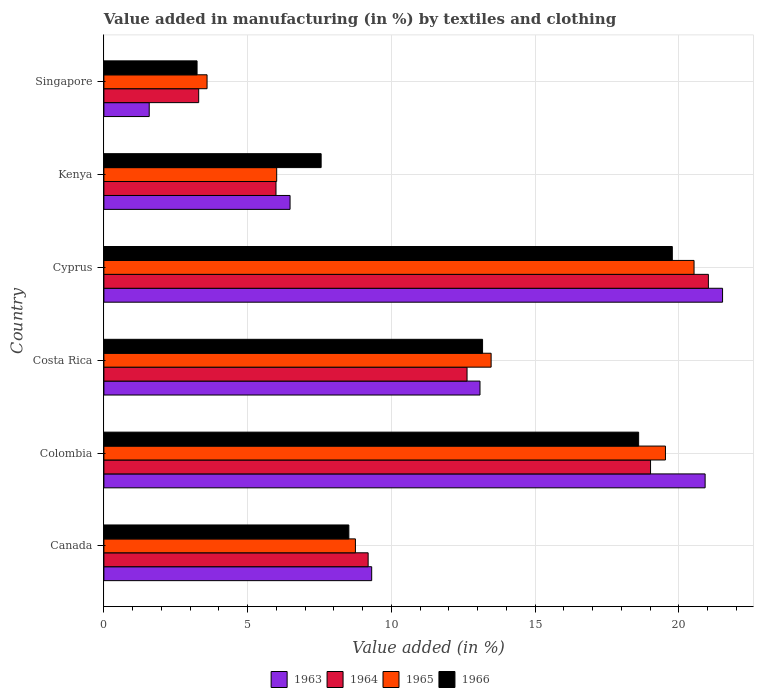Are the number of bars per tick equal to the number of legend labels?
Give a very brief answer. Yes. Are the number of bars on each tick of the Y-axis equal?
Keep it short and to the point. Yes. What is the label of the 1st group of bars from the top?
Offer a terse response. Singapore. What is the percentage of value added in manufacturing by textiles and clothing in 1966 in Kenya?
Offer a terse response. 7.56. Across all countries, what is the maximum percentage of value added in manufacturing by textiles and clothing in 1966?
Offer a very short reply. 19.78. Across all countries, what is the minimum percentage of value added in manufacturing by textiles and clothing in 1963?
Your answer should be very brief. 1.58. In which country was the percentage of value added in manufacturing by textiles and clothing in 1964 maximum?
Your response must be concise. Cyprus. In which country was the percentage of value added in manufacturing by textiles and clothing in 1965 minimum?
Your answer should be very brief. Singapore. What is the total percentage of value added in manufacturing by textiles and clothing in 1964 in the graph?
Your answer should be very brief. 71.16. What is the difference between the percentage of value added in manufacturing by textiles and clothing in 1964 in Canada and that in Singapore?
Keep it short and to the point. 5.9. What is the difference between the percentage of value added in manufacturing by textiles and clothing in 1966 in Cyprus and the percentage of value added in manufacturing by textiles and clothing in 1964 in Canada?
Provide a short and direct response. 10.58. What is the average percentage of value added in manufacturing by textiles and clothing in 1963 per country?
Your response must be concise. 12.15. What is the difference between the percentage of value added in manufacturing by textiles and clothing in 1966 and percentage of value added in manufacturing by textiles and clothing in 1965 in Colombia?
Offer a terse response. -0.93. What is the ratio of the percentage of value added in manufacturing by textiles and clothing in 1963 in Canada to that in Kenya?
Provide a short and direct response. 1.44. Is the percentage of value added in manufacturing by textiles and clothing in 1963 in Canada less than that in Kenya?
Offer a very short reply. No. What is the difference between the highest and the second highest percentage of value added in manufacturing by textiles and clothing in 1963?
Make the answer very short. 0.61. What is the difference between the highest and the lowest percentage of value added in manufacturing by textiles and clothing in 1964?
Your response must be concise. 17.73. Is the sum of the percentage of value added in manufacturing by textiles and clothing in 1963 in Canada and Kenya greater than the maximum percentage of value added in manufacturing by textiles and clothing in 1964 across all countries?
Your response must be concise. No. What does the 3rd bar from the bottom in Singapore represents?
Provide a succinct answer. 1965. How many bars are there?
Keep it short and to the point. 24. What is the difference between two consecutive major ticks on the X-axis?
Your answer should be very brief. 5. Are the values on the major ticks of X-axis written in scientific E-notation?
Make the answer very short. No. Does the graph contain any zero values?
Offer a very short reply. No. How many legend labels are there?
Keep it short and to the point. 4. What is the title of the graph?
Provide a succinct answer. Value added in manufacturing (in %) by textiles and clothing. What is the label or title of the X-axis?
Offer a terse response. Value added (in %). What is the label or title of the Y-axis?
Provide a succinct answer. Country. What is the Value added (in %) of 1963 in Canada?
Provide a succinct answer. 9.32. What is the Value added (in %) in 1964 in Canada?
Make the answer very short. 9.19. What is the Value added (in %) in 1965 in Canada?
Ensure brevity in your answer.  8.75. What is the Value added (in %) in 1966 in Canada?
Your answer should be compact. 8.52. What is the Value added (in %) in 1963 in Colombia?
Offer a terse response. 20.92. What is the Value added (in %) in 1964 in Colombia?
Make the answer very short. 19.02. What is the Value added (in %) in 1965 in Colombia?
Give a very brief answer. 19.54. What is the Value added (in %) in 1966 in Colombia?
Provide a succinct answer. 18.6. What is the Value added (in %) of 1963 in Costa Rica?
Make the answer very short. 13.08. What is the Value added (in %) in 1964 in Costa Rica?
Your answer should be very brief. 12.63. What is the Value added (in %) in 1965 in Costa Rica?
Your answer should be very brief. 13.47. What is the Value added (in %) of 1966 in Costa Rica?
Make the answer very short. 13.17. What is the Value added (in %) of 1963 in Cyprus?
Your answer should be very brief. 21.52. What is the Value added (in %) of 1964 in Cyprus?
Offer a very short reply. 21.03. What is the Value added (in %) of 1965 in Cyprus?
Offer a terse response. 20.53. What is the Value added (in %) in 1966 in Cyprus?
Make the answer very short. 19.78. What is the Value added (in %) in 1963 in Kenya?
Your response must be concise. 6.48. What is the Value added (in %) of 1964 in Kenya?
Offer a very short reply. 5.99. What is the Value added (in %) of 1965 in Kenya?
Provide a succinct answer. 6.01. What is the Value added (in %) of 1966 in Kenya?
Offer a very short reply. 7.56. What is the Value added (in %) of 1963 in Singapore?
Offer a very short reply. 1.58. What is the Value added (in %) of 1964 in Singapore?
Your answer should be compact. 3.3. What is the Value added (in %) in 1965 in Singapore?
Give a very brief answer. 3.59. What is the Value added (in %) in 1966 in Singapore?
Provide a succinct answer. 3.24. Across all countries, what is the maximum Value added (in %) of 1963?
Make the answer very short. 21.52. Across all countries, what is the maximum Value added (in %) of 1964?
Provide a succinct answer. 21.03. Across all countries, what is the maximum Value added (in %) in 1965?
Give a very brief answer. 20.53. Across all countries, what is the maximum Value added (in %) in 1966?
Make the answer very short. 19.78. Across all countries, what is the minimum Value added (in %) in 1963?
Offer a very short reply. 1.58. Across all countries, what is the minimum Value added (in %) of 1964?
Offer a terse response. 3.3. Across all countries, what is the minimum Value added (in %) in 1965?
Ensure brevity in your answer.  3.59. Across all countries, what is the minimum Value added (in %) of 1966?
Provide a short and direct response. 3.24. What is the total Value added (in %) of 1963 in the graph?
Keep it short and to the point. 72.9. What is the total Value added (in %) in 1964 in the graph?
Offer a terse response. 71.16. What is the total Value added (in %) in 1965 in the graph?
Your answer should be very brief. 71.89. What is the total Value added (in %) of 1966 in the graph?
Your answer should be compact. 70.87. What is the difference between the Value added (in %) of 1963 in Canada and that in Colombia?
Offer a very short reply. -11.6. What is the difference between the Value added (in %) of 1964 in Canada and that in Colombia?
Your response must be concise. -9.82. What is the difference between the Value added (in %) of 1965 in Canada and that in Colombia?
Ensure brevity in your answer.  -10.79. What is the difference between the Value added (in %) of 1966 in Canada and that in Colombia?
Your response must be concise. -10.08. What is the difference between the Value added (in %) of 1963 in Canada and that in Costa Rica?
Your response must be concise. -3.77. What is the difference between the Value added (in %) in 1964 in Canada and that in Costa Rica?
Your response must be concise. -3.44. What is the difference between the Value added (in %) in 1965 in Canada and that in Costa Rica?
Ensure brevity in your answer.  -4.72. What is the difference between the Value added (in %) in 1966 in Canada and that in Costa Rica?
Give a very brief answer. -4.65. What is the difference between the Value added (in %) of 1963 in Canada and that in Cyprus?
Offer a terse response. -12.21. What is the difference between the Value added (in %) in 1964 in Canada and that in Cyprus?
Ensure brevity in your answer.  -11.84. What is the difference between the Value added (in %) of 1965 in Canada and that in Cyprus?
Provide a short and direct response. -11.78. What is the difference between the Value added (in %) of 1966 in Canada and that in Cyprus?
Ensure brevity in your answer.  -11.25. What is the difference between the Value added (in %) in 1963 in Canada and that in Kenya?
Your response must be concise. 2.84. What is the difference between the Value added (in %) in 1964 in Canada and that in Kenya?
Make the answer very short. 3.21. What is the difference between the Value added (in %) in 1965 in Canada and that in Kenya?
Your answer should be compact. 2.74. What is the difference between the Value added (in %) of 1966 in Canada and that in Kenya?
Your response must be concise. 0.96. What is the difference between the Value added (in %) of 1963 in Canada and that in Singapore?
Your answer should be compact. 7.74. What is the difference between the Value added (in %) in 1964 in Canada and that in Singapore?
Provide a short and direct response. 5.9. What is the difference between the Value added (in %) in 1965 in Canada and that in Singapore?
Your response must be concise. 5.16. What is the difference between the Value added (in %) in 1966 in Canada and that in Singapore?
Make the answer very short. 5.28. What is the difference between the Value added (in %) of 1963 in Colombia and that in Costa Rica?
Make the answer very short. 7.83. What is the difference between the Value added (in %) of 1964 in Colombia and that in Costa Rica?
Provide a succinct answer. 6.38. What is the difference between the Value added (in %) in 1965 in Colombia and that in Costa Rica?
Ensure brevity in your answer.  6.06. What is the difference between the Value added (in %) in 1966 in Colombia and that in Costa Rica?
Your answer should be very brief. 5.43. What is the difference between the Value added (in %) of 1963 in Colombia and that in Cyprus?
Give a very brief answer. -0.61. What is the difference between the Value added (in %) of 1964 in Colombia and that in Cyprus?
Keep it short and to the point. -2.01. What is the difference between the Value added (in %) in 1965 in Colombia and that in Cyprus?
Keep it short and to the point. -0.99. What is the difference between the Value added (in %) of 1966 in Colombia and that in Cyprus?
Provide a succinct answer. -1.17. What is the difference between the Value added (in %) of 1963 in Colombia and that in Kenya?
Give a very brief answer. 14.44. What is the difference between the Value added (in %) of 1964 in Colombia and that in Kenya?
Your response must be concise. 13.03. What is the difference between the Value added (in %) in 1965 in Colombia and that in Kenya?
Your answer should be very brief. 13.53. What is the difference between the Value added (in %) in 1966 in Colombia and that in Kenya?
Give a very brief answer. 11.05. What is the difference between the Value added (in %) of 1963 in Colombia and that in Singapore?
Offer a terse response. 19.34. What is the difference between the Value added (in %) of 1964 in Colombia and that in Singapore?
Keep it short and to the point. 15.72. What is the difference between the Value added (in %) in 1965 in Colombia and that in Singapore?
Keep it short and to the point. 15.95. What is the difference between the Value added (in %) of 1966 in Colombia and that in Singapore?
Keep it short and to the point. 15.36. What is the difference between the Value added (in %) of 1963 in Costa Rica and that in Cyprus?
Provide a succinct answer. -8.44. What is the difference between the Value added (in %) in 1964 in Costa Rica and that in Cyprus?
Ensure brevity in your answer.  -8.4. What is the difference between the Value added (in %) in 1965 in Costa Rica and that in Cyprus?
Your answer should be very brief. -7.06. What is the difference between the Value added (in %) of 1966 in Costa Rica and that in Cyprus?
Keep it short and to the point. -6.6. What is the difference between the Value added (in %) of 1963 in Costa Rica and that in Kenya?
Offer a terse response. 6.61. What is the difference between the Value added (in %) of 1964 in Costa Rica and that in Kenya?
Offer a terse response. 6.65. What is the difference between the Value added (in %) in 1965 in Costa Rica and that in Kenya?
Give a very brief answer. 7.46. What is the difference between the Value added (in %) in 1966 in Costa Rica and that in Kenya?
Give a very brief answer. 5.62. What is the difference between the Value added (in %) in 1963 in Costa Rica and that in Singapore?
Your answer should be compact. 11.51. What is the difference between the Value added (in %) of 1964 in Costa Rica and that in Singapore?
Provide a succinct answer. 9.34. What is the difference between the Value added (in %) of 1965 in Costa Rica and that in Singapore?
Your response must be concise. 9.88. What is the difference between the Value added (in %) in 1966 in Costa Rica and that in Singapore?
Ensure brevity in your answer.  9.93. What is the difference between the Value added (in %) in 1963 in Cyprus and that in Kenya?
Provide a succinct answer. 15.05. What is the difference between the Value added (in %) in 1964 in Cyprus and that in Kenya?
Your response must be concise. 15.04. What is the difference between the Value added (in %) in 1965 in Cyprus and that in Kenya?
Give a very brief answer. 14.52. What is the difference between the Value added (in %) of 1966 in Cyprus and that in Kenya?
Your answer should be very brief. 12.22. What is the difference between the Value added (in %) in 1963 in Cyprus and that in Singapore?
Your answer should be compact. 19.95. What is the difference between the Value added (in %) in 1964 in Cyprus and that in Singapore?
Offer a very short reply. 17.73. What is the difference between the Value added (in %) of 1965 in Cyprus and that in Singapore?
Your response must be concise. 16.94. What is the difference between the Value added (in %) in 1966 in Cyprus and that in Singapore?
Offer a terse response. 16.53. What is the difference between the Value added (in %) in 1963 in Kenya and that in Singapore?
Offer a terse response. 4.9. What is the difference between the Value added (in %) in 1964 in Kenya and that in Singapore?
Offer a very short reply. 2.69. What is the difference between the Value added (in %) of 1965 in Kenya and that in Singapore?
Make the answer very short. 2.42. What is the difference between the Value added (in %) in 1966 in Kenya and that in Singapore?
Your response must be concise. 4.32. What is the difference between the Value added (in %) in 1963 in Canada and the Value added (in %) in 1964 in Colombia?
Provide a short and direct response. -9.7. What is the difference between the Value added (in %) in 1963 in Canada and the Value added (in %) in 1965 in Colombia?
Give a very brief answer. -10.22. What is the difference between the Value added (in %) in 1963 in Canada and the Value added (in %) in 1966 in Colombia?
Provide a succinct answer. -9.29. What is the difference between the Value added (in %) in 1964 in Canada and the Value added (in %) in 1965 in Colombia?
Keep it short and to the point. -10.34. What is the difference between the Value added (in %) in 1964 in Canada and the Value added (in %) in 1966 in Colombia?
Offer a very short reply. -9.41. What is the difference between the Value added (in %) of 1965 in Canada and the Value added (in %) of 1966 in Colombia?
Your response must be concise. -9.85. What is the difference between the Value added (in %) of 1963 in Canada and the Value added (in %) of 1964 in Costa Rica?
Ensure brevity in your answer.  -3.32. What is the difference between the Value added (in %) of 1963 in Canada and the Value added (in %) of 1965 in Costa Rica?
Provide a succinct answer. -4.16. What is the difference between the Value added (in %) in 1963 in Canada and the Value added (in %) in 1966 in Costa Rica?
Ensure brevity in your answer.  -3.86. What is the difference between the Value added (in %) in 1964 in Canada and the Value added (in %) in 1965 in Costa Rica?
Make the answer very short. -4.28. What is the difference between the Value added (in %) of 1964 in Canada and the Value added (in %) of 1966 in Costa Rica?
Offer a very short reply. -3.98. What is the difference between the Value added (in %) of 1965 in Canada and the Value added (in %) of 1966 in Costa Rica?
Your answer should be compact. -4.42. What is the difference between the Value added (in %) in 1963 in Canada and the Value added (in %) in 1964 in Cyprus?
Keep it short and to the point. -11.71. What is the difference between the Value added (in %) of 1963 in Canada and the Value added (in %) of 1965 in Cyprus?
Your answer should be compact. -11.21. What is the difference between the Value added (in %) of 1963 in Canada and the Value added (in %) of 1966 in Cyprus?
Offer a terse response. -10.46. What is the difference between the Value added (in %) in 1964 in Canada and the Value added (in %) in 1965 in Cyprus?
Your answer should be compact. -11.34. What is the difference between the Value added (in %) in 1964 in Canada and the Value added (in %) in 1966 in Cyprus?
Offer a terse response. -10.58. What is the difference between the Value added (in %) in 1965 in Canada and the Value added (in %) in 1966 in Cyprus?
Give a very brief answer. -11.02. What is the difference between the Value added (in %) in 1963 in Canada and the Value added (in %) in 1964 in Kenya?
Keep it short and to the point. 3.33. What is the difference between the Value added (in %) of 1963 in Canada and the Value added (in %) of 1965 in Kenya?
Give a very brief answer. 3.31. What is the difference between the Value added (in %) in 1963 in Canada and the Value added (in %) in 1966 in Kenya?
Your answer should be compact. 1.76. What is the difference between the Value added (in %) of 1964 in Canada and the Value added (in %) of 1965 in Kenya?
Your answer should be compact. 3.18. What is the difference between the Value added (in %) in 1964 in Canada and the Value added (in %) in 1966 in Kenya?
Make the answer very short. 1.64. What is the difference between the Value added (in %) in 1965 in Canada and the Value added (in %) in 1966 in Kenya?
Offer a terse response. 1.19. What is the difference between the Value added (in %) in 1963 in Canada and the Value added (in %) in 1964 in Singapore?
Ensure brevity in your answer.  6.02. What is the difference between the Value added (in %) in 1963 in Canada and the Value added (in %) in 1965 in Singapore?
Your answer should be very brief. 5.73. What is the difference between the Value added (in %) in 1963 in Canada and the Value added (in %) in 1966 in Singapore?
Your response must be concise. 6.08. What is the difference between the Value added (in %) in 1964 in Canada and the Value added (in %) in 1965 in Singapore?
Ensure brevity in your answer.  5.6. What is the difference between the Value added (in %) of 1964 in Canada and the Value added (in %) of 1966 in Singapore?
Offer a terse response. 5.95. What is the difference between the Value added (in %) of 1965 in Canada and the Value added (in %) of 1966 in Singapore?
Give a very brief answer. 5.51. What is the difference between the Value added (in %) in 1963 in Colombia and the Value added (in %) in 1964 in Costa Rica?
Offer a very short reply. 8.28. What is the difference between the Value added (in %) of 1963 in Colombia and the Value added (in %) of 1965 in Costa Rica?
Your answer should be compact. 7.44. What is the difference between the Value added (in %) in 1963 in Colombia and the Value added (in %) in 1966 in Costa Rica?
Give a very brief answer. 7.74. What is the difference between the Value added (in %) of 1964 in Colombia and the Value added (in %) of 1965 in Costa Rica?
Offer a very short reply. 5.55. What is the difference between the Value added (in %) of 1964 in Colombia and the Value added (in %) of 1966 in Costa Rica?
Offer a very short reply. 5.84. What is the difference between the Value added (in %) in 1965 in Colombia and the Value added (in %) in 1966 in Costa Rica?
Provide a short and direct response. 6.36. What is the difference between the Value added (in %) of 1963 in Colombia and the Value added (in %) of 1964 in Cyprus?
Offer a very short reply. -0.11. What is the difference between the Value added (in %) of 1963 in Colombia and the Value added (in %) of 1965 in Cyprus?
Provide a short and direct response. 0.39. What is the difference between the Value added (in %) of 1963 in Colombia and the Value added (in %) of 1966 in Cyprus?
Your response must be concise. 1.14. What is the difference between the Value added (in %) in 1964 in Colombia and the Value added (in %) in 1965 in Cyprus?
Your answer should be very brief. -1.51. What is the difference between the Value added (in %) of 1964 in Colombia and the Value added (in %) of 1966 in Cyprus?
Provide a short and direct response. -0.76. What is the difference between the Value added (in %) of 1965 in Colombia and the Value added (in %) of 1966 in Cyprus?
Keep it short and to the point. -0.24. What is the difference between the Value added (in %) in 1963 in Colombia and the Value added (in %) in 1964 in Kenya?
Offer a terse response. 14.93. What is the difference between the Value added (in %) of 1963 in Colombia and the Value added (in %) of 1965 in Kenya?
Offer a very short reply. 14.91. What is the difference between the Value added (in %) in 1963 in Colombia and the Value added (in %) in 1966 in Kenya?
Offer a terse response. 13.36. What is the difference between the Value added (in %) in 1964 in Colombia and the Value added (in %) in 1965 in Kenya?
Give a very brief answer. 13.01. What is the difference between the Value added (in %) of 1964 in Colombia and the Value added (in %) of 1966 in Kenya?
Ensure brevity in your answer.  11.46. What is the difference between the Value added (in %) of 1965 in Colombia and the Value added (in %) of 1966 in Kenya?
Offer a very short reply. 11.98. What is the difference between the Value added (in %) in 1963 in Colombia and the Value added (in %) in 1964 in Singapore?
Offer a terse response. 17.62. What is the difference between the Value added (in %) in 1963 in Colombia and the Value added (in %) in 1965 in Singapore?
Ensure brevity in your answer.  17.33. What is the difference between the Value added (in %) in 1963 in Colombia and the Value added (in %) in 1966 in Singapore?
Ensure brevity in your answer.  17.68. What is the difference between the Value added (in %) of 1964 in Colombia and the Value added (in %) of 1965 in Singapore?
Give a very brief answer. 15.43. What is the difference between the Value added (in %) in 1964 in Colombia and the Value added (in %) in 1966 in Singapore?
Your answer should be very brief. 15.78. What is the difference between the Value added (in %) in 1965 in Colombia and the Value added (in %) in 1966 in Singapore?
Offer a terse response. 16.3. What is the difference between the Value added (in %) in 1963 in Costa Rica and the Value added (in %) in 1964 in Cyprus?
Keep it short and to the point. -7.95. What is the difference between the Value added (in %) of 1963 in Costa Rica and the Value added (in %) of 1965 in Cyprus?
Provide a short and direct response. -7.45. What is the difference between the Value added (in %) of 1963 in Costa Rica and the Value added (in %) of 1966 in Cyprus?
Give a very brief answer. -6.69. What is the difference between the Value added (in %) of 1964 in Costa Rica and the Value added (in %) of 1965 in Cyprus?
Your answer should be compact. -7.9. What is the difference between the Value added (in %) in 1964 in Costa Rica and the Value added (in %) in 1966 in Cyprus?
Your response must be concise. -7.14. What is the difference between the Value added (in %) in 1965 in Costa Rica and the Value added (in %) in 1966 in Cyprus?
Ensure brevity in your answer.  -6.3. What is the difference between the Value added (in %) in 1963 in Costa Rica and the Value added (in %) in 1964 in Kenya?
Keep it short and to the point. 7.1. What is the difference between the Value added (in %) in 1963 in Costa Rica and the Value added (in %) in 1965 in Kenya?
Your response must be concise. 7.07. What is the difference between the Value added (in %) of 1963 in Costa Rica and the Value added (in %) of 1966 in Kenya?
Your answer should be compact. 5.53. What is the difference between the Value added (in %) in 1964 in Costa Rica and the Value added (in %) in 1965 in Kenya?
Provide a short and direct response. 6.62. What is the difference between the Value added (in %) of 1964 in Costa Rica and the Value added (in %) of 1966 in Kenya?
Your answer should be compact. 5.08. What is the difference between the Value added (in %) in 1965 in Costa Rica and the Value added (in %) in 1966 in Kenya?
Make the answer very short. 5.91. What is the difference between the Value added (in %) of 1963 in Costa Rica and the Value added (in %) of 1964 in Singapore?
Provide a succinct answer. 9.79. What is the difference between the Value added (in %) in 1963 in Costa Rica and the Value added (in %) in 1965 in Singapore?
Provide a succinct answer. 9.5. What is the difference between the Value added (in %) in 1963 in Costa Rica and the Value added (in %) in 1966 in Singapore?
Make the answer very short. 9.84. What is the difference between the Value added (in %) in 1964 in Costa Rica and the Value added (in %) in 1965 in Singapore?
Your response must be concise. 9.04. What is the difference between the Value added (in %) in 1964 in Costa Rica and the Value added (in %) in 1966 in Singapore?
Provide a succinct answer. 9.39. What is the difference between the Value added (in %) of 1965 in Costa Rica and the Value added (in %) of 1966 in Singapore?
Keep it short and to the point. 10.23. What is the difference between the Value added (in %) of 1963 in Cyprus and the Value added (in %) of 1964 in Kenya?
Offer a terse response. 15.54. What is the difference between the Value added (in %) in 1963 in Cyprus and the Value added (in %) in 1965 in Kenya?
Make the answer very short. 15.51. What is the difference between the Value added (in %) in 1963 in Cyprus and the Value added (in %) in 1966 in Kenya?
Provide a short and direct response. 13.97. What is the difference between the Value added (in %) in 1964 in Cyprus and the Value added (in %) in 1965 in Kenya?
Provide a short and direct response. 15.02. What is the difference between the Value added (in %) of 1964 in Cyprus and the Value added (in %) of 1966 in Kenya?
Offer a very short reply. 13.47. What is the difference between the Value added (in %) in 1965 in Cyprus and the Value added (in %) in 1966 in Kenya?
Give a very brief answer. 12.97. What is the difference between the Value added (in %) of 1963 in Cyprus and the Value added (in %) of 1964 in Singapore?
Keep it short and to the point. 18.23. What is the difference between the Value added (in %) in 1963 in Cyprus and the Value added (in %) in 1965 in Singapore?
Provide a short and direct response. 17.93. What is the difference between the Value added (in %) in 1963 in Cyprus and the Value added (in %) in 1966 in Singapore?
Your answer should be very brief. 18.28. What is the difference between the Value added (in %) in 1964 in Cyprus and the Value added (in %) in 1965 in Singapore?
Your answer should be compact. 17.44. What is the difference between the Value added (in %) of 1964 in Cyprus and the Value added (in %) of 1966 in Singapore?
Your answer should be compact. 17.79. What is the difference between the Value added (in %) in 1965 in Cyprus and the Value added (in %) in 1966 in Singapore?
Make the answer very short. 17.29. What is the difference between the Value added (in %) of 1963 in Kenya and the Value added (in %) of 1964 in Singapore?
Provide a short and direct response. 3.18. What is the difference between the Value added (in %) of 1963 in Kenya and the Value added (in %) of 1965 in Singapore?
Make the answer very short. 2.89. What is the difference between the Value added (in %) of 1963 in Kenya and the Value added (in %) of 1966 in Singapore?
Make the answer very short. 3.24. What is the difference between the Value added (in %) in 1964 in Kenya and the Value added (in %) in 1965 in Singapore?
Provide a succinct answer. 2.4. What is the difference between the Value added (in %) in 1964 in Kenya and the Value added (in %) in 1966 in Singapore?
Ensure brevity in your answer.  2.75. What is the difference between the Value added (in %) in 1965 in Kenya and the Value added (in %) in 1966 in Singapore?
Make the answer very short. 2.77. What is the average Value added (in %) in 1963 per country?
Your response must be concise. 12.15. What is the average Value added (in %) in 1964 per country?
Provide a short and direct response. 11.86. What is the average Value added (in %) of 1965 per country?
Make the answer very short. 11.98. What is the average Value added (in %) of 1966 per country?
Your answer should be very brief. 11.81. What is the difference between the Value added (in %) in 1963 and Value added (in %) in 1964 in Canada?
Give a very brief answer. 0.12. What is the difference between the Value added (in %) in 1963 and Value added (in %) in 1965 in Canada?
Your response must be concise. 0.57. What is the difference between the Value added (in %) of 1963 and Value added (in %) of 1966 in Canada?
Ensure brevity in your answer.  0.8. What is the difference between the Value added (in %) in 1964 and Value added (in %) in 1965 in Canada?
Provide a succinct answer. 0.44. What is the difference between the Value added (in %) of 1964 and Value added (in %) of 1966 in Canada?
Ensure brevity in your answer.  0.67. What is the difference between the Value added (in %) of 1965 and Value added (in %) of 1966 in Canada?
Make the answer very short. 0.23. What is the difference between the Value added (in %) in 1963 and Value added (in %) in 1964 in Colombia?
Keep it short and to the point. 1.9. What is the difference between the Value added (in %) of 1963 and Value added (in %) of 1965 in Colombia?
Keep it short and to the point. 1.38. What is the difference between the Value added (in %) in 1963 and Value added (in %) in 1966 in Colombia?
Your answer should be compact. 2.31. What is the difference between the Value added (in %) in 1964 and Value added (in %) in 1965 in Colombia?
Offer a very short reply. -0.52. What is the difference between the Value added (in %) of 1964 and Value added (in %) of 1966 in Colombia?
Offer a very short reply. 0.41. What is the difference between the Value added (in %) in 1965 and Value added (in %) in 1966 in Colombia?
Ensure brevity in your answer.  0.93. What is the difference between the Value added (in %) of 1963 and Value added (in %) of 1964 in Costa Rica?
Your answer should be very brief. 0.45. What is the difference between the Value added (in %) of 1963 and Value added (in %) of 1965 in Costa Rica?
Ensure brevity in your answer.  -0.39. What is the difference between the Value added (in %) of 1963 and Value added (in %) of 1966 in Costa Rica?
Provide a succinct answer. -0.09. What is the difference between the Value added (in %) of 1964 and Value added (in %) of 1965 in Costa Rica?
Provide a succinct answer. -0.84. What is the difference between the Value added (in %) of 1964 and Value added (in %) of 1966 in Costa Rica?
Make the answer very short. -0.54. What is the difference between the Value added (in %) of 1965 and Value added (in %) of 1966 in Costa Rica?
Offer a very short reply. 0.3. What is the difference between the Value added (in %) in 1963 and Value added (in %) in 1964 in Cyprus?
Make the answer very short. 0.49. What is the difference between the Value added (in %) in 1963 and Value added (in %) in 1966 in Cyprus?
Offer a terse response. 1.75. What is the difference between the Value added (in %) of 1964 and Value added (in %) of 1965 in Cyprus?
Offer a very short reply. 0.5. What is the difference between the Value added (in %) of 1964 and Value added (in %) of 1966 in Cyprus?
Give a very brief answer. 1.25. What is the difference between the Value added (in %) of 1965 and Value added (in %) of 1966 in Cyprus?
Make the answer very short. 0.76. What is the difference between the Value added (in %) of 1963 and Value added (in %) of 1964 in Kenya?
Offer a terse response. 0.49. What is the difference between the Value added (in %) in 1963 and Value added (in %) in 1965 in Kenya?
Your answer should be compact. 0.47. What is the difference between the Value added (in %) in 1963 and Value added (in %) in 1966 in Kenya?
Make the answer very short. -1.08. What is the difference between the Value added (in %) of 1964 and Value added (in %) of 1965 in Kenya?
Offer a very short reply. -0.02. What is the difference between the Value added (in %) in 1964 and Value added (in %) in 1966 in Kenya?
Keep it short and to the point. -1.57. What is the difference between the Value added (in %) of 1965 and Value added (in %) of 1966 in Kenya?
Provide a short and direct response. -1.55. What is the difference between the Value added (in %) in 1963 and Value added (in %) in 1964 in Singapore?
Give a very brief answer. -1.72. What is the difference between the Value added (in %) in 1963 and Value added (in %) in 1965 in Singapore?
Your answer should be very brief. -2.01. What is the difference between the Value added (in %) of 1963 and Value added (in %) of 1966 in Singapore?
Provide a succinct answer. -1.66. What is the difference between the Value added (in %) of 1964 and Value added (in %) of 1965 in Singapore?
Offer a very short reply. -0.29. What is the difference between the Value added (in %) of 1964 and Value added (in %) of 1966 in Singapore?
Your response must be concise. 0.06. What is the difference between the Value added (in %) of 1965 and Value added (in %) of 1966 in Singapore?
Offer a terse response. 0.35. What is the ratio of the Value added (in %) in 1963 in Canada to that in Colombia?
Ensure brevity in your answer.  0.45. What is the ratio of the Value added (in %) in 1964 in Canada to that in Colombia?
Offer a very short reply. 0.48. What is the ratio of the Value added (in %) of 1965 in Canada to that in Colombia?
Ensure brevity in your answer.  0.45. What is the ratio of the Value added (in %) of 1966 in Canada to that in Colombia?
Ensure brevity in your answer.  0.46. What is the ratio of the Value added (in %) in 1963 in Canada to that in Costa Rica?
Ensure brevity in your answer.  0.71. What is the ratio of the Value added (in %) of 1964 in Canada to that in Costa Rica?
Provide a succinct answer. 0.73. What is the ratio of the Value added (in %) of 1965 in Canada to that in Costa Rica?
Make the answer very short. 0.65. What is the ratio of the Value added (in %) in 1966 in Canada to that in Costa Rica?
Your response must be concise. 0.65. What is the ratio of the Value added (in %) in 1963 in Canada to that in Cyprus?
Make the answer very short. 0.43. What is the ratio of the Value added (in %) in 1964 in Canada to that in Cyprus?
Your response must be concise. 0.44. What is the ratio of the Value added (in %) in 1965 in Canada to that in Cyprus?
Provide a short and direct response. 0.43. What is the ratio of the Value added (in %) of 1966 in Canada to that in Cyprus?
Your response must be concise. 0.43. What is the ratio of the Value added (in %) in 1963 in Canada to that in Kenya?
Provide a short and direct response. 1.44. What is the ratio of the Value added (in %) in 1964 in Canada to that in Kenya?
Offer a very short reply. 1.54. What is the ratio of the Value added (in %) in 1965 in Canada to that in Kenya?
Make the answer very short. 1.46. What is the ratio of the Value added (in %) in 1966 in Canada to that in Kenya?
Provide a short and direct response. 1.13. What is the ratio of the Value added (in %) of 1963 in Canada to that in Singapore?
Your answer should be very brief. 5.91. What is the ratio of the Value added (in %) in 1964 in Canada to that in Singapore?
Offer a terse response. 2.79. What is the ratio of the Value added (in %) of 1965 in Canada to that in Singapore?
Offer a very short reply. 2.44. What is the ratio of the Value added (in %) in 1966 in Canada to that in Singapore?
Your answer should be very brief. 2.63. What is the ratio of the Value added (in %) in 1963 in Colombia to that in Costa Rica?
Your answer should be compact. 1.6. What is the ratio of the Value added (in %) in 1964 in Colombia to that in Costa Rica?
Ensure brevity in your answer.  1.51. What is the ratio of the Value added (in %) in 1965 in Colombia to that in Costa Rica?
Keep it short and to the point. 1.45. What is the ratio of the Value added (in %) of 1966 in Colombia to that in Costa Rica?
Your answer should be very brief. 1.41. What is the ratio of the Value added (in %) in 1963 in Colombia to that in Cyprus?
Your answer should be compact. 0.97. What is the ratio of the Value added (in %) of 1964 in Colombia to that in Cyprus?
Offer a terse response. 0.9. What is the ratio of the Value added (in %) in 1965 in Colombia to that in Cyprus?
Your response must be concise. 0.95. What is the ratio of the Value added (in %) of 1966 in Colombia to that in Cyprus?
Offer a very short reply. 0.94. What is the ratio of the Value added (in %) in 1963 in Colombia to that in Kenya?
Offer a very short reply. 3.23. What is the ratio of the Value added (in %) in 1964 in Colombia to that in Kenya?
Ensure brevity in your answer.  3.18. What is the ratio of the Value added (in %) of 1966 in Colombia to that in Kenya?
Provide a succinct answer. 2.46. What is the ratio of the Value added (in %) in 1963 in Colombia to that in Singapore?
Your response must be concise. 13.26. What is the ratio of the Value added (in %) of 1964 in Colombia to that in Singapore?
Make the answer very short. 5.77. What is the ratio of the Value added (in %) of 1965 in Colombia to that in Singapore?
Offer a very short reply. 5.44. What is the ratio of the Value added (in %) in 1966 in Colombia to that in Singapore?
Your answer should be compact. 5.74. What is the ratio of the Value added (in %) of 1963 in Costa Rica to that in Cyprus?
Your response must be concise. 0.61. What is the ratio of the Value added (in %) of 1964 in Costa Rica to that in Cyprus?
Offer a very short reply. 0.6. What is the ratio of the Value added (in %) in 1965 in Costa Rica to that in Cyprus?
Make the answer very short. 0.66. What is the ratio of the Value added (in %) in 1966 in Costa Rica to that in Cyprus?
Ensure brevity in your answer.  0.67. What is the ratio of the Value added (in %) of 1963 in Costa Rica to that in Kenya?
Your response must be concise. 2.02. What is the ratio of the Value added (in %) of 1964 in Costa Rica to that in Kenya?
Provide a short and direct response. 2.11. What is the ratio of the Value added (in %) in 1965 in Costa Rica to that in Kenya?
Your response must be concise. 2.24. What is the ratio of the Value added (in %) in 1966 in Costa Rica to that in Kenya?
Your response must be concise. 1.74. What is the ratio of the Value added (in %) in 1963 in Costa Rica to that in Singapore?
Make the answer very short. 8.3. What is the ratio of the Value added (in %) in 1964 in Costa Rica to that in Singapore?
Offer a very short reply. 3.83. What is the ratio of the Value added (in %) in 1965 in Costa Rica to that in Singapore?
Make the answer very short. 3.75. What is the ratio of the Value added (in %) of 1966 in Costa Rica to that in Singapore?
Your answer should be compact. 4.06. What is the ratio of the Value added (in %) of 1963 in Cyprus to that in Kenya?
Offer a very short reply. 3.32. What is the ratio of the Value added (in %) in 1964 in Cyprus to that in Kenya?
Give a very brief answer. 3.51. What is the ratio of the Value added (in %) in 1965 in Cyprus to that in Kenya?
Your answer should be compact. 3.42. What is the ratio of the Value added (in %) in 1966 in Cyprus to that in Kenya?
Ensure brevity in your answer.  2.62. What is the ratio of the Value added (in %) in 1963 in Cyprus to that in Singapore?
Provide a short and direct response. 13.65. What is the ratio of the Value added (in %) of 1964 in Cyprus to that in Singapore?
Provide a short and direct response. 6.38. What is the ratio of the Value added (in %) in 1965 in Cyprus to that in Singapore?
Offer a very short reply. 5.72. What is the ratio of the Value added (in %) of 1966 in Cyprus to that in Singapore?
Provide a succinct answer. 6.1. What is the ratio of the Value added (in %) of 1963 in Kenya to that in Singapore?
Your response must be concise. 4.11. What is the ratio of the Value added (in %) of 1964 in Kenya to that in Singapore?
Provide a short and direct response. 1.82. What is the ratio of the Value added (in %) of 1965 in Kenya to that in Singapore?
Give a very brief answer. 1.67. What is the ratio of the Value added (in %) in 1966 in Kenya to that in Singapore?
Your response must be concise. 2.33. What is the difference between the highest and the second highest Value added (in %) in 1963?
Provide a short and direct response. 0.61. What is the difference between the highest and the second highest Value added (in %) in 1964?
Provide a succinct answer. 2.01. What is the difference between the highest and the second highest Value added (in %) of 1966?
Your answer should be very brief. 1.17. What is the difference between the highest and the lowest Value added (in %) of 1963?
Make the answer very short. 19.95. What is the difference between the highest and the lowest Value added (in %) of 1964?
Your response must be concise. 17.73. What is the difference between the highest and the lowest Value added (in %) in 1965?
Provide a succinct answer. 16.94. What is the difference between the highest and the lowest Value added (in %) of 1966?
Make the answer very short. 16.53. 